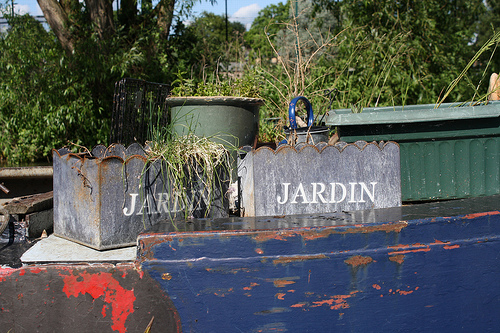<image>
Is there a letters on the window box? No. The letters is not positioned on the window box. They may be near each other, but the letters is not supported by or resting on top of the window box. 